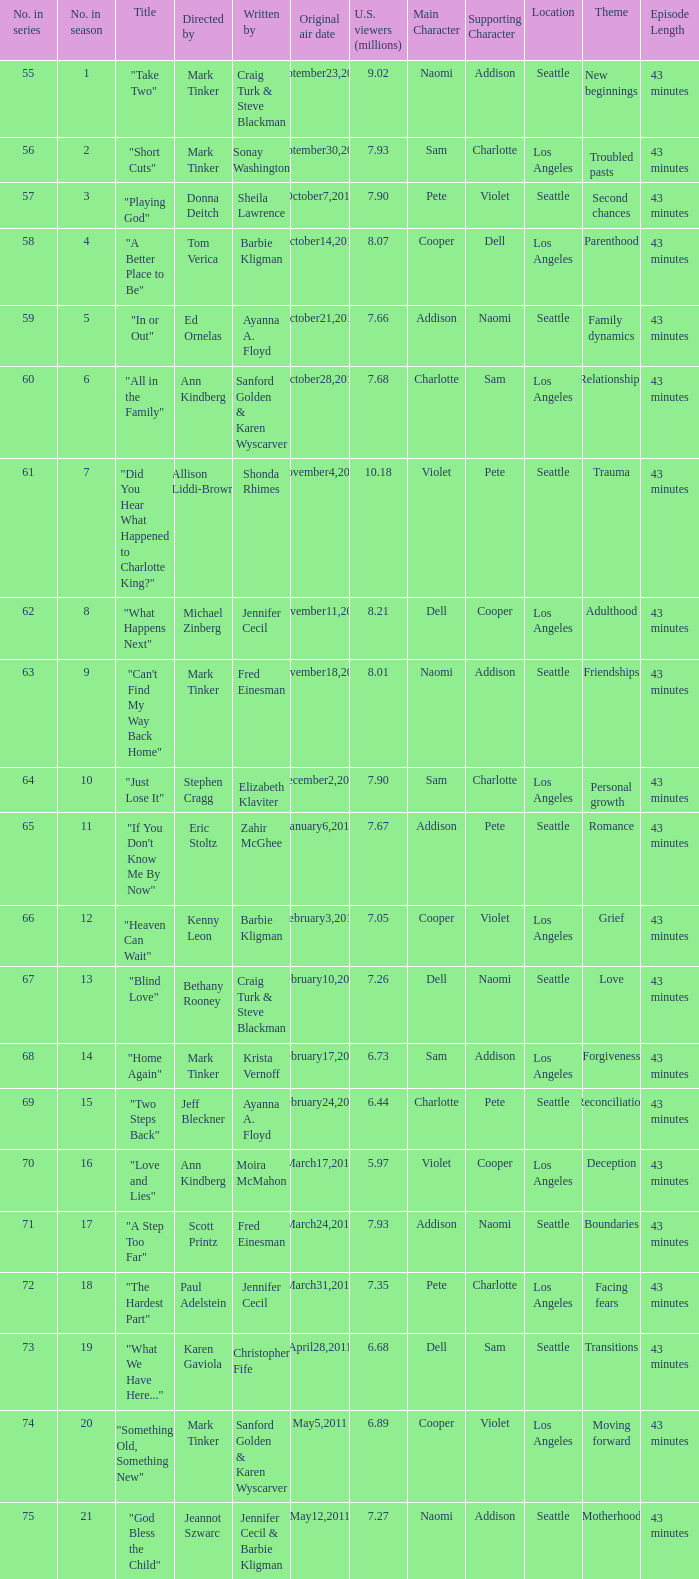Would you mind parsing the complete table? {'header': ['No. in series', 'No. in season', 'Title', 'Directed by', 'Written by', 'Original air date', 'U.S. viewers (millions)', 'Main Character', 'Supporting Character', 'Location', 'Theme', 'Episode Length'], 'rows': [['55', '1', '"Take Two"', 'Mark Tinker', 'Craig Turk & Steve Blackman', 'September23,2010', '9.02', 'Naomi', 'Addison', 'Seattle', 'New beginnings', '43 minutes'], ['56', '2', '"Short Cuts"', 'Mark Tinker', 'Sonay Washington', 'September30,2010', '7.93', 'Sam', 'Charlotte', 'Los Angeles', 'Troubled pasts', '43 minutes'], ['57', '3', '"Playing God"', 'Donna Deitch', 'Sheila Lawrence', 'October7,2010', '7.90', 'Pete', 'Violet', 'Seattle', 'Second chances', '43 minutes'], ['58', '4', '"A Better Place to Be"', 'Tom Verica', 'Barbie Kligman', 'October14,2010', '8.07', 'Cooper', 'Dell', 'Los Angeles', 'Parenthood', '43 minutes'], ['59', '5', '"In or Out"', 'Ed Ornelas', 'Ayanna A. Floyd', 'October21,2010', '7.66', 'Addison', 'Naomi', 'Seattle', 'Family dynamics', '43 minutes'], ['60', '6', '"All in the Family"', 'Ann Kindberg', 'Sanford Golden & Karen Wyscarver', 'October28,2010', '7.68', 'Charlotte', 'Sam', 'Los Angeles', 'Relationships', '43 minutes'], ['61', '7', '"Did You Hear What Happened to Charlotte King?"', 'Allison Liddi-Brown', 'Shonda Rhimes', 'November4,2010', '10.18', 'Violet', 'Pete', 'Seattle', 'Trauma', '43 minutes'], ['62', '8', '"What Happens Next"', 'Michael Zinberg', 'Jennifer Cecil', 'November11,2010', '8.21', 'Dell', 'Cooper', 'Los Angeles', 'Adulthood', '43 minutes'], ['63', '9', '"Can\'t Find My Way Back Home"', 'Mark Tinker', 'Fred Einesman', 'November18,2010', '8.01', 'Naomi', 'Addison', 'Seattle', 'Friendships', '43 minutes'], ['64', '10', '"Just Lose It"', 'Stephen Cragg', 'Elizabeth Klaviter', 'December2,2010', '7.90', 'Sam', 'Charlotte', 'Los Angeles', 'Personal growth', '43 minutes'], ['65', '11', '"If You Don\'t Know Me By Now"', 'Eric Stoltz', 'Zahir McGhee', 'January6,2011', '7.67', 'Addison', 'Pete', 'Seattle', 'Romance', '43 minutes'], ['66', '12', '"Heaven Can Wait"', 'Kenny Leon', 'Barbie Kligman', 'February3,2011', '7.05', 'Cooper', 'Violet', 'Los Angeles', 'Grief', '43 minutes'], ['67', '13', '"Blind Love"', 'Bethany Rooney', 'Craig Turk & Steve Blackman', 'February10,2011', '7.26', 'Dell', 'Naomi', 'Seattle', 'Love', '43 minutes'], ['68', '14', '"Home Again"', 'Mark Tinker', 'Krista Vernoff', 'February17,2011', '6.73', 'Sam', 'Addison', 'Los Angeles', 'Forgiveness', '43 minutes'], ['69', '15', '"Two Steps Back"', 'Jeff Bleckner', 'Ayanna A. Floyd', 'February24,2011', '6.44', 'Charlotte', 'Pete', 'Seattle', 'Reconciliation', '43 minutes'], ['70', '16', '"Love and Lies"', 'Ann Kindberg', 'Moira McMahon', 'March17,2011', '5.97', 'Violet', 'Cooper', 'Los Angeles', 'Deception', '43 minutes'], ['71', '17', '"A Step Too Far"', 'Scott Printz', 'Fred Einesman', 'March24,2011', '7.93', 'Addison', 'Naomi', 'Seattle', 'Boundaries', '43 minutes'], ['72', '18', '"The Hardest Part"', 'Paul Adelstein', 'Jennifer Cecil', 'March31,2011', '7.35', 'Pete', 'Charlotte', 'Los Angeles', 'Facing fears', '43 minutes'], ['73', '19', '"What We Have Here..."', 'Karen Gaviola', 'Christopher Fife', 'April28,2011', '6.68', 'Dell', 'Sam', 'Seattle', 'Transitions', '43 minutes'], ['74', '20', '"Something Old, Something New"', 'Mark Tinker', 'Sanford Golden & Karen Wyscarver', 'May5,2011', '6.89', 'Cooper', 'Violet', 'Los Angeles', 'Moving forward', '43 minutes'], ['75', '21', '"God Bless the Child"', 'Jeannot Szwarc', 'Jennifer Cecil & Barbie Kligman', 'May12,2011', '7.27', 'Naomi', 'Addison', 'Seattle', 'Motherhood', '43 minutes']]} What is the earliest numbered episode of the season? 1.0. 